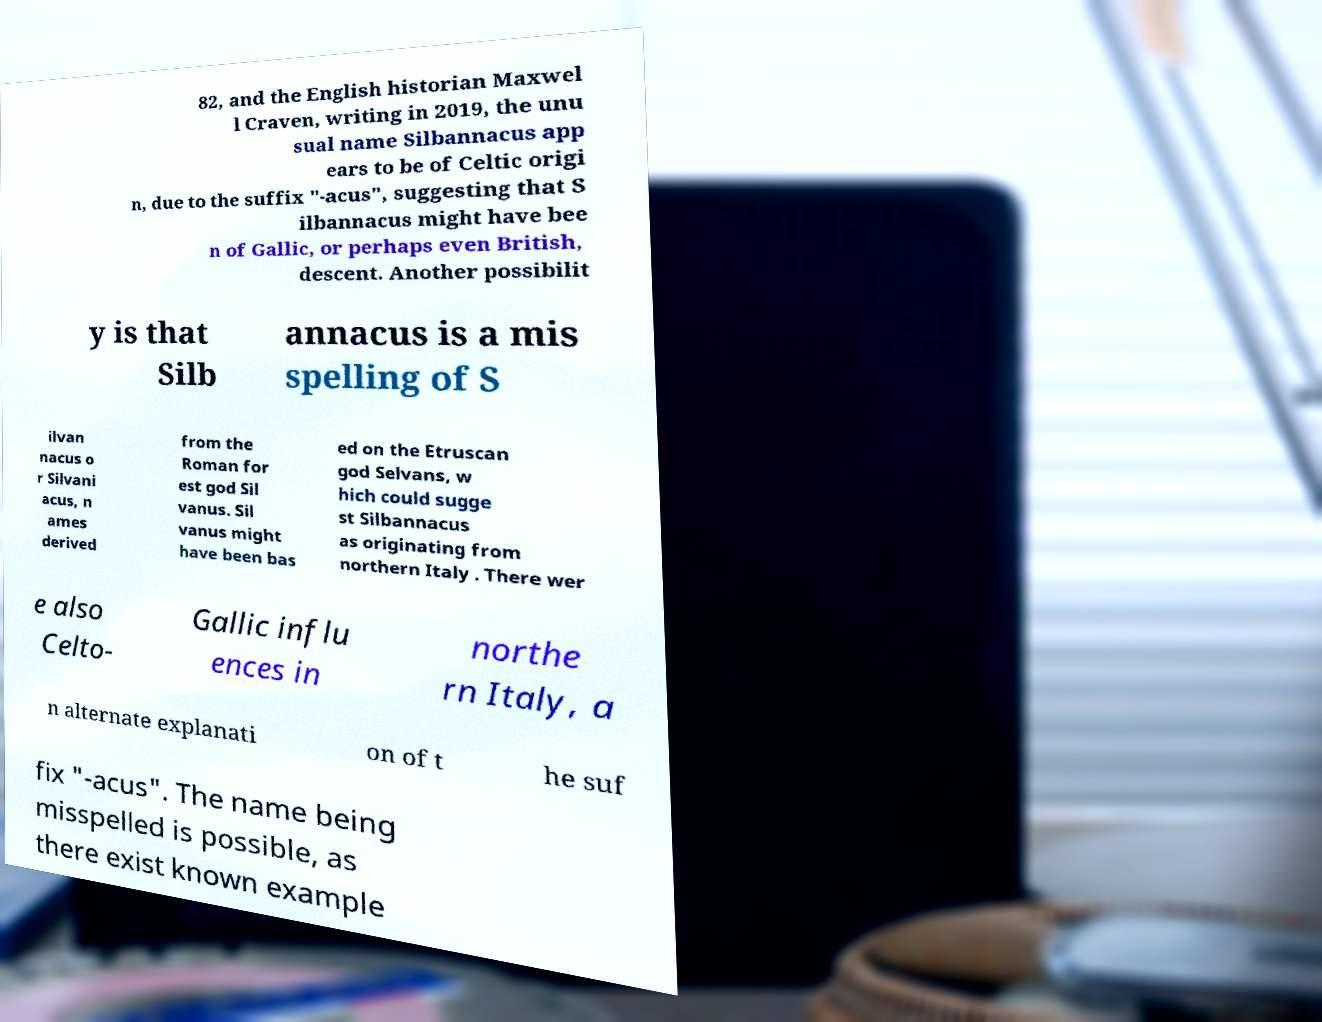Please read and relay the text visible in this image. What does it say? 82, and the English historian Maxwel l Craven, writing in 2019, the unu sual name Silbannacus app ears to be of Celtic origi n, due to the suffix "-acus", suggesting that S ilbannacus might have bee n of Gallic, or perhaps even British, descent. Another possibilit y is that Silb annacus is a mis spelling of S ilvan nacus o r Silvani acus, n ames derived from the Roman for est god Sil vanus. Sil vanus might have been bas ed on the Etruscan god Selvans, w hich could sugge st Silbannacus as originating from northern Italy . There wer e also Celto- Gallic influ ences in northe rn Italy, a n alternate explanati on of t he suf fix "-acus". The name being misspelled is possible, as there exist known example 